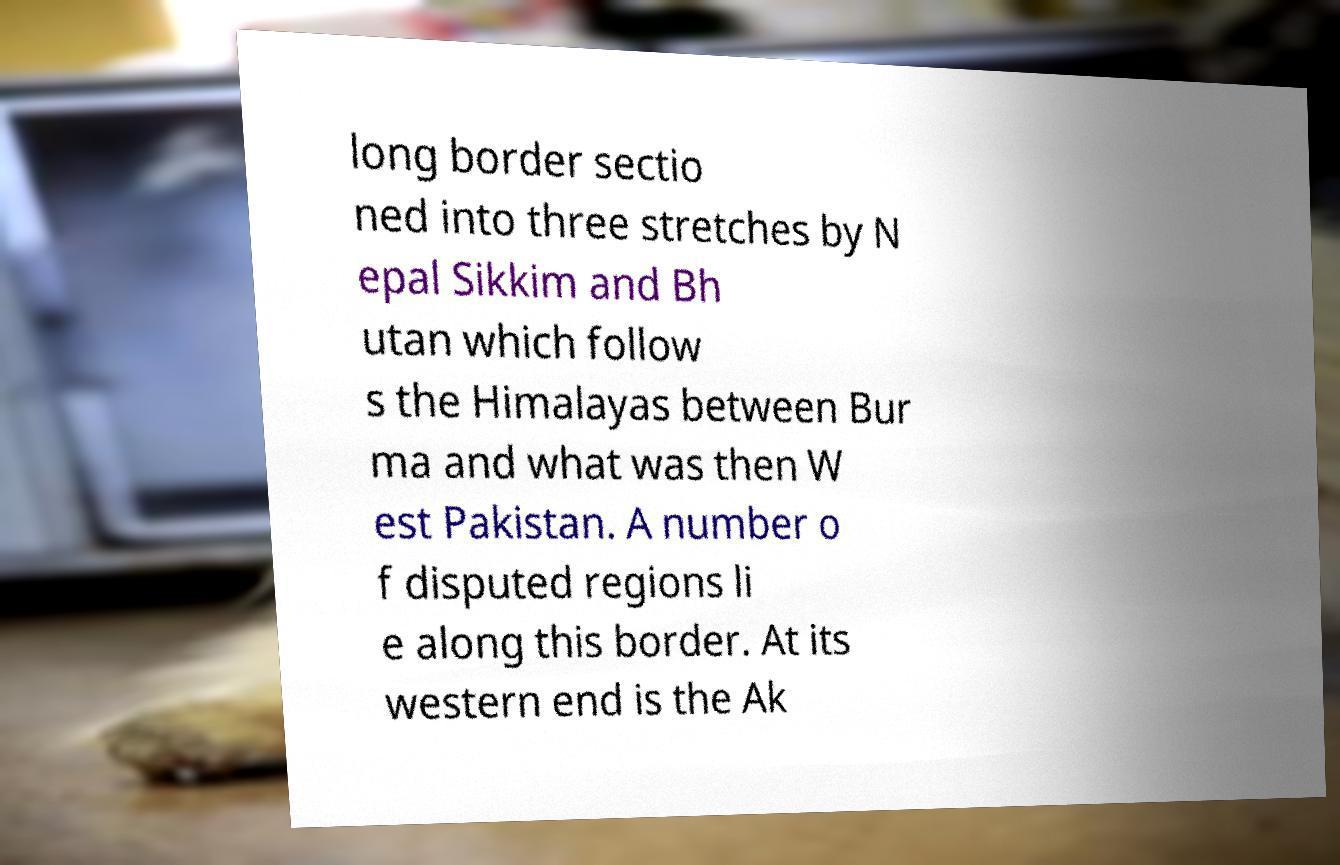Could you extract and type out the text from this image? long border sectio ned into three stretches by N epal Sikkim and Bh utan which follow s the Himalayas between Bur ma and what was then W est Pakistan. A number o f disputed regions li e along this border. At its western end is the Ak 